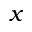<formula> <loc_0><loc_0><loc_500><loc_500>x</formula> 